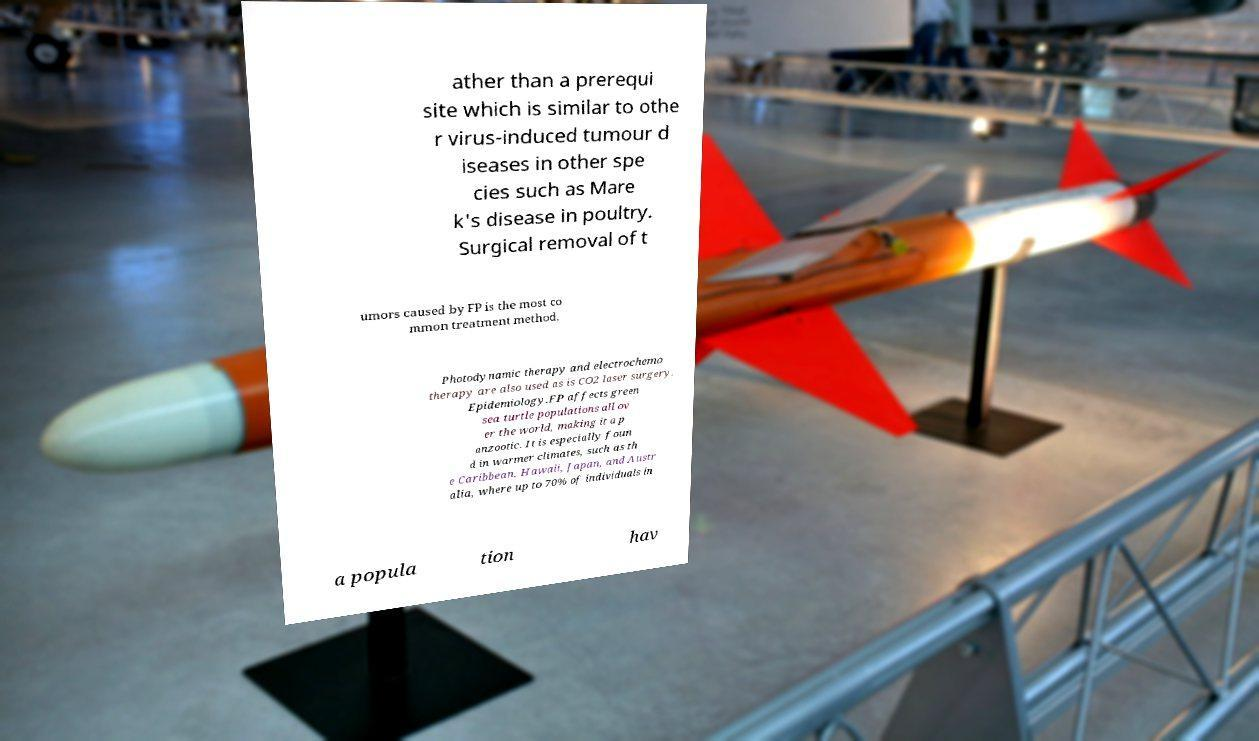What messages or text are displayed in this image? I need them in a readable, typed format. ather than a prerequi site which is similar to othe r virus-induced tumour d iseases in other spe cies such as Mare k's disease in poultry. Surgical removal of t umors caused by FP is the most co mmon treatment method. Photodynamic therapy and electrochemo therapy are also used as is CO2 laser surgery. Epidemiology.FP affects green sea turtle populations all ov er the world, making it a p anzootic. It is especially foun d in warmer climates, such as th e Caribbean, Hawaii, Japan, and Austr alia, where up to 70% of individuals in a popula tion hav 